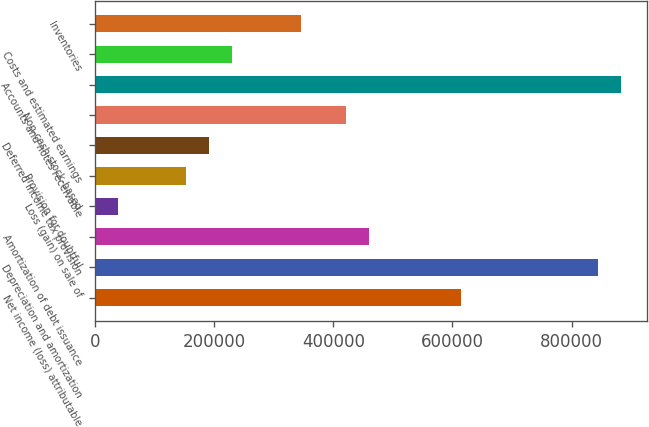<chart> <loc_0><loc_0><loc_500><loc_500><bar_chart><fcel>Net income (loss) attributable<fcel>Depreciation and amortization<fcel>Amortization of debt issuance<fcel>Loss (gain) on sale of<fcel>Provision for doubtful<fcel>Deferred income tax provision<fcel>Non-cash stock-based<fcel>Accounts and notes receivable<fcel>Costs and estimated earnings<fcel>Inventories<nl><fcel>613828<fcel>843970<fcel>460401<fcel>38474.9<fcel>153546<fcel>191902<fcel>422044<fcel>882327<fcel>230259<fcel>345330<nl></chart> 